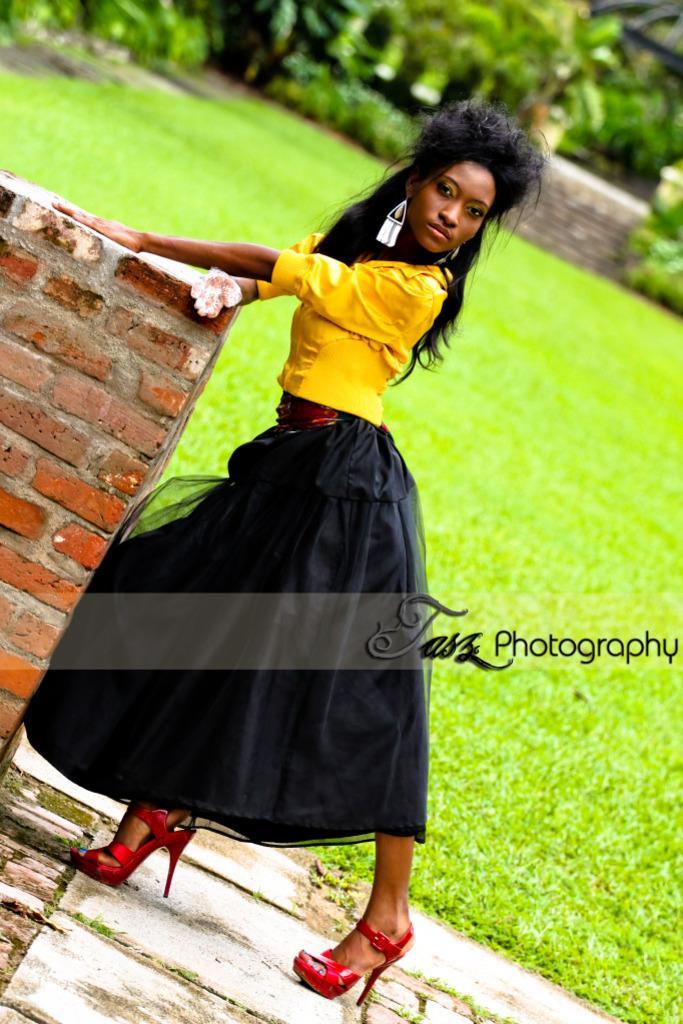In one or two sentences, can you explain what this image depicts? In this image, there is an outside view. There is a person in the middle of the image wearing clothes and standing beside the wall. 